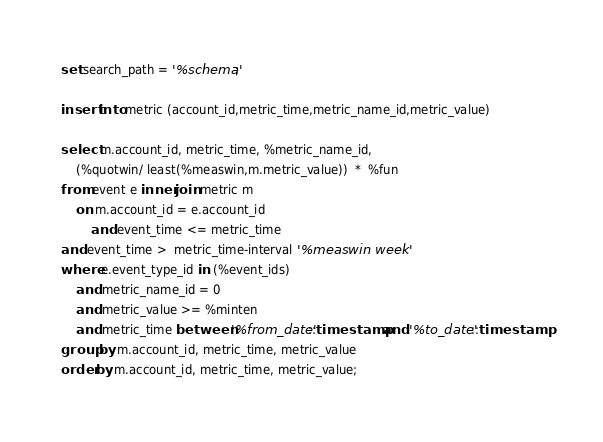<code> <loc_0><loc_0><loc_500><loc_500><_SQL_>set search_path = '%schema';

insert into metric (account_id,metric_time,metric_name_id,metric_value)

select m.account_id, metric_time, %metric_name_id,
    (%quotwin/ least(%measwin,m.metric_value))  *  %fun
from event e inner join metric m
    on m.account_id = e.account_id
    	and event_time <= metric_time
and event_time >  metric_time-interval '%measwin week'
where e.event_type_id in (%event_ids)
    and metric_name_id = 0
    and metric_value >= %minten
    and metric_time between '%from_date'::timestamp and '%to_date'::timestamp
group by m.account_id, metric_time, metric_value
order by m.account_id, metric_time, metric_value;
</code> 